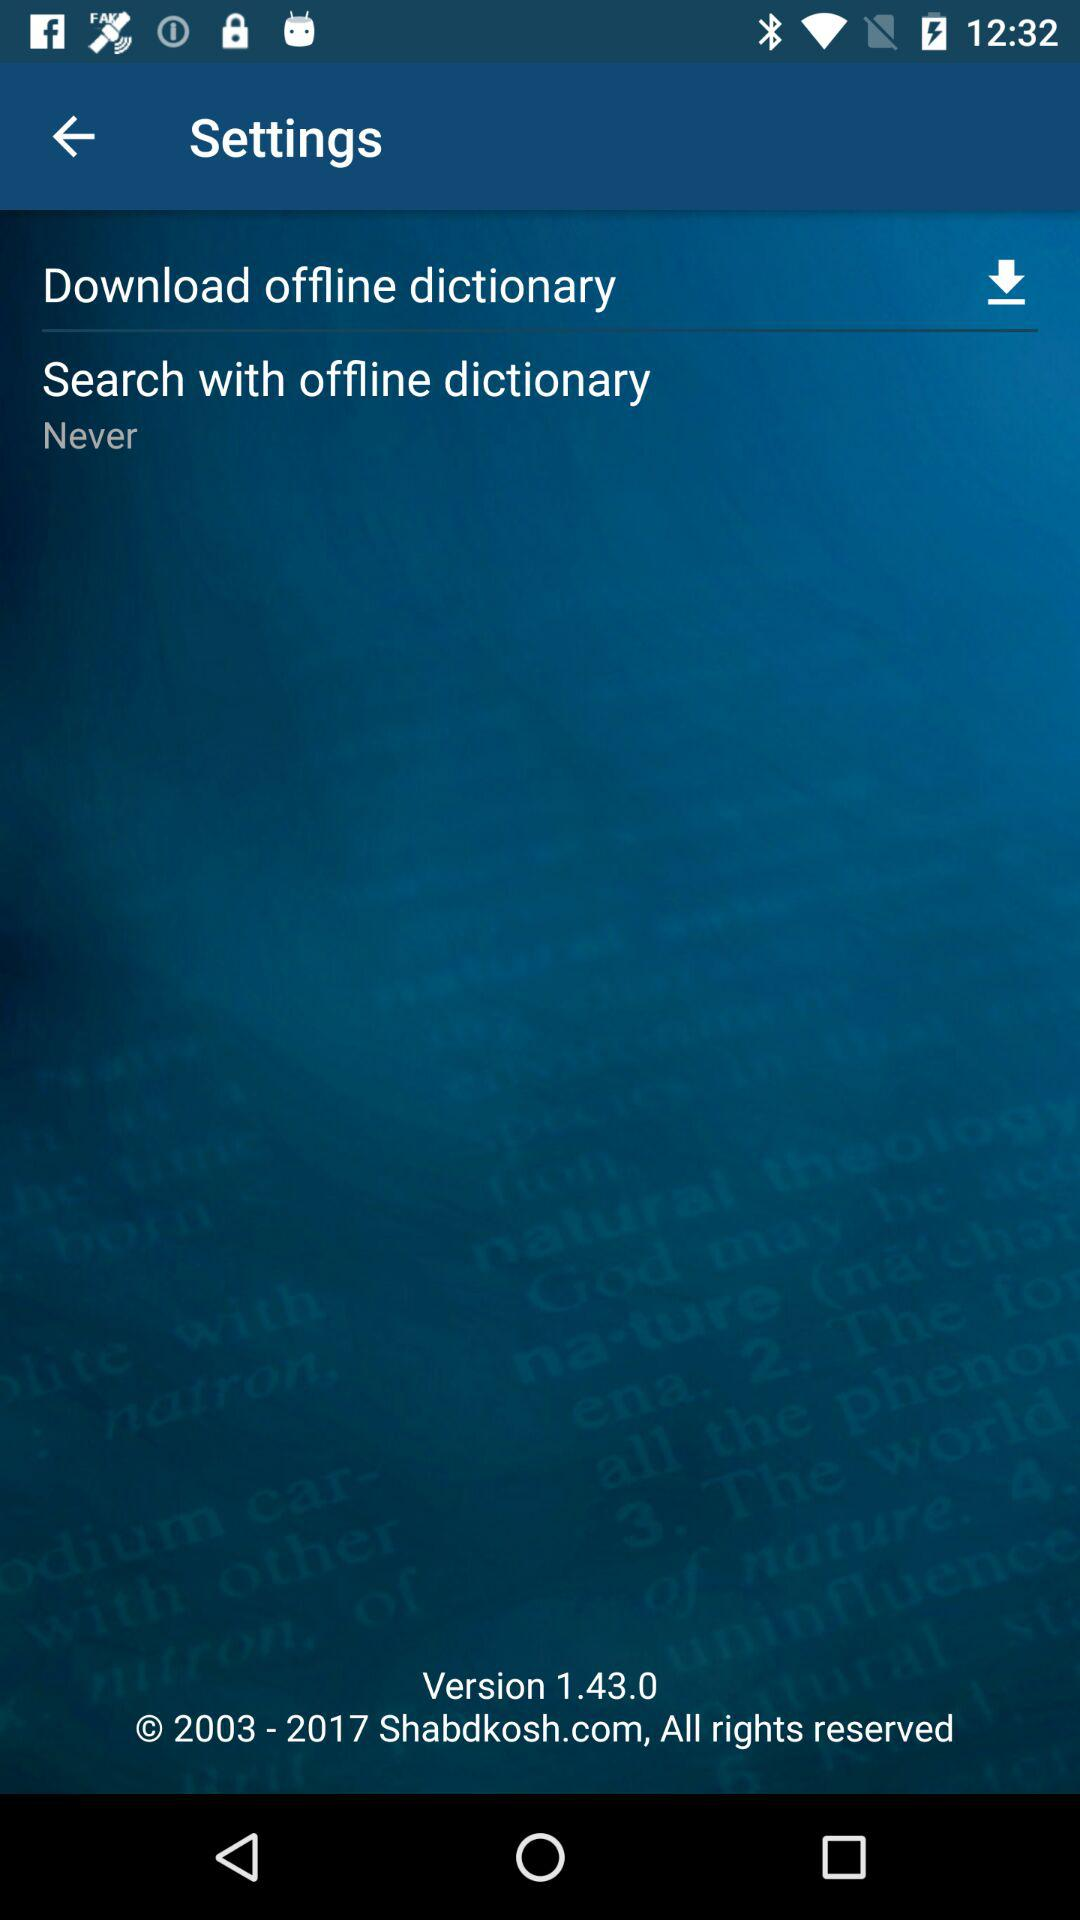What is the name of the application?
When the provided information is insufficient, respond with <no answer>. <no answer> 